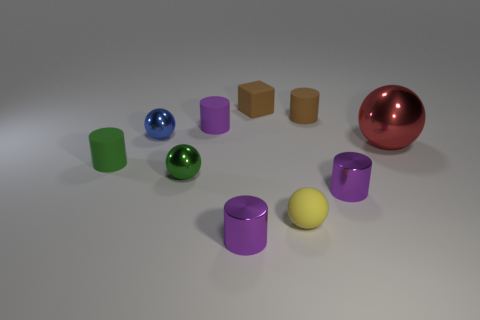How many purple cylinders must be subtracted to get 1 purple cylinders? 2 Subtract all green spheres. How many purple cylinders are left? 3 Subtract all brown cylinders. How many cylinders are left? 4 Subtract all tiny green cylinders. How many cylinders are left? 4 Subtract all cyan cylinders. Subtract all yellow spheres. How many cylinders are left? 5 Subtract all cubes. How many objects are left? 9 Subtract all small brown shiny things. Subtract all blue things. How many objects are left? 9 Add 4 shiny cylinders. How many shiny cylinders are left? 6 Add 5 tiny blue rubber spheres. How many tiny blue rubber spheres exist? 5 Subtract 0 brown balls. How many objects are left? 10 